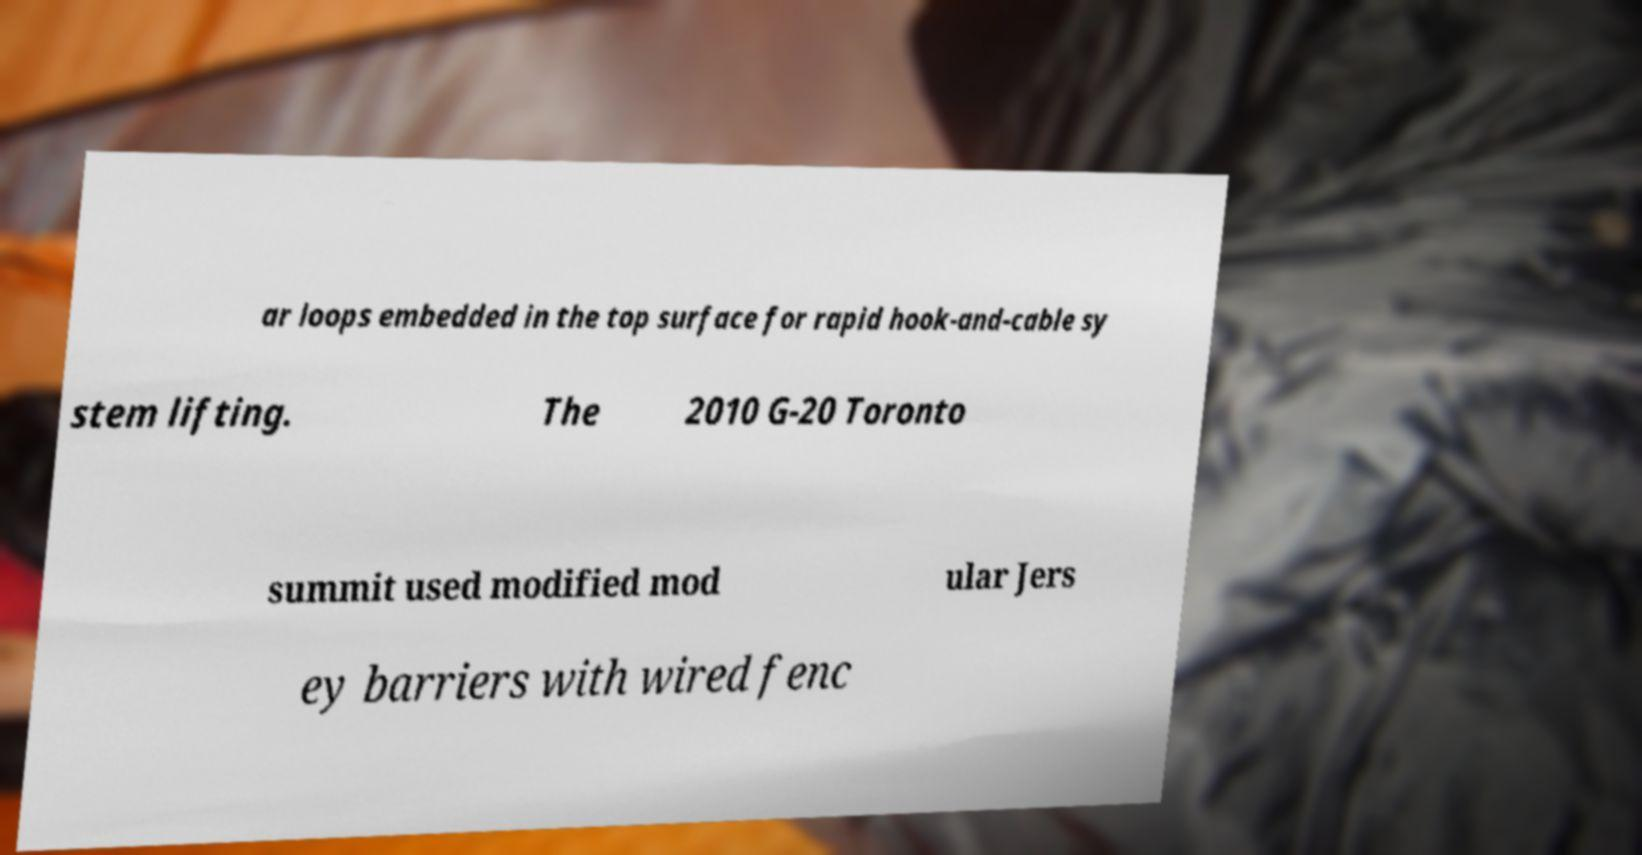There's text embedded in this image that I need extracted. Can you transcribe it verbatim? ar loops embedded in the top surface for rapid hook-and-cable sy stem lifting. The 2010 G-20 Toronto summit used modified mod ular Jers ey barriers with wired fenc 